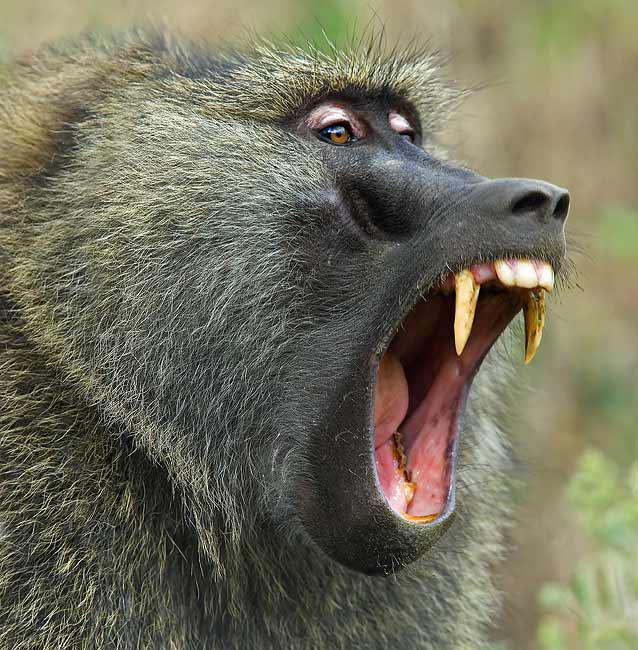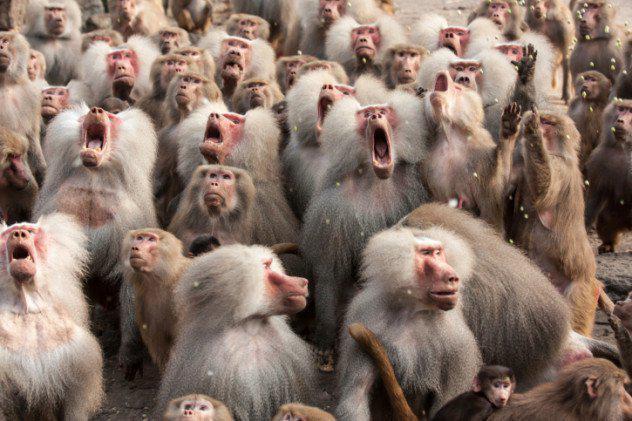The first image is the image on the left, the second image is the image on the right. For the images displayed, is the sentence "An image shows the bulbous pinkish rear of one adult baboon." factually correct? Answer yes or no. No. The first image is the image on the left, the second image is the image on the right. For the images shown, is this caption "There is exactly one animal in one of the images." true? Answer yes or no. Yes. The first image is the image on the left, the second image is the image on the right. Given the left and right images, does the statement "There is a single babboon in one of the images." hold true? Answer yes or no. Yes. The first image is the image on the left, the second image is the image on the right. Evaluate the accuracy of this statement regarding the images: "One image depicts at aleast a dozen baboons posed on a dry surface.". Is it true? Answer yes or no. Yes. 